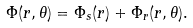Convert formula to latex. <formula><loc_0><loc_0><loc_500><loc_500>\Phi ( r , \theta ) = \Phi _ { s } ( r ) + \Phi _ { r } ( r , \theta ) .</formula> 